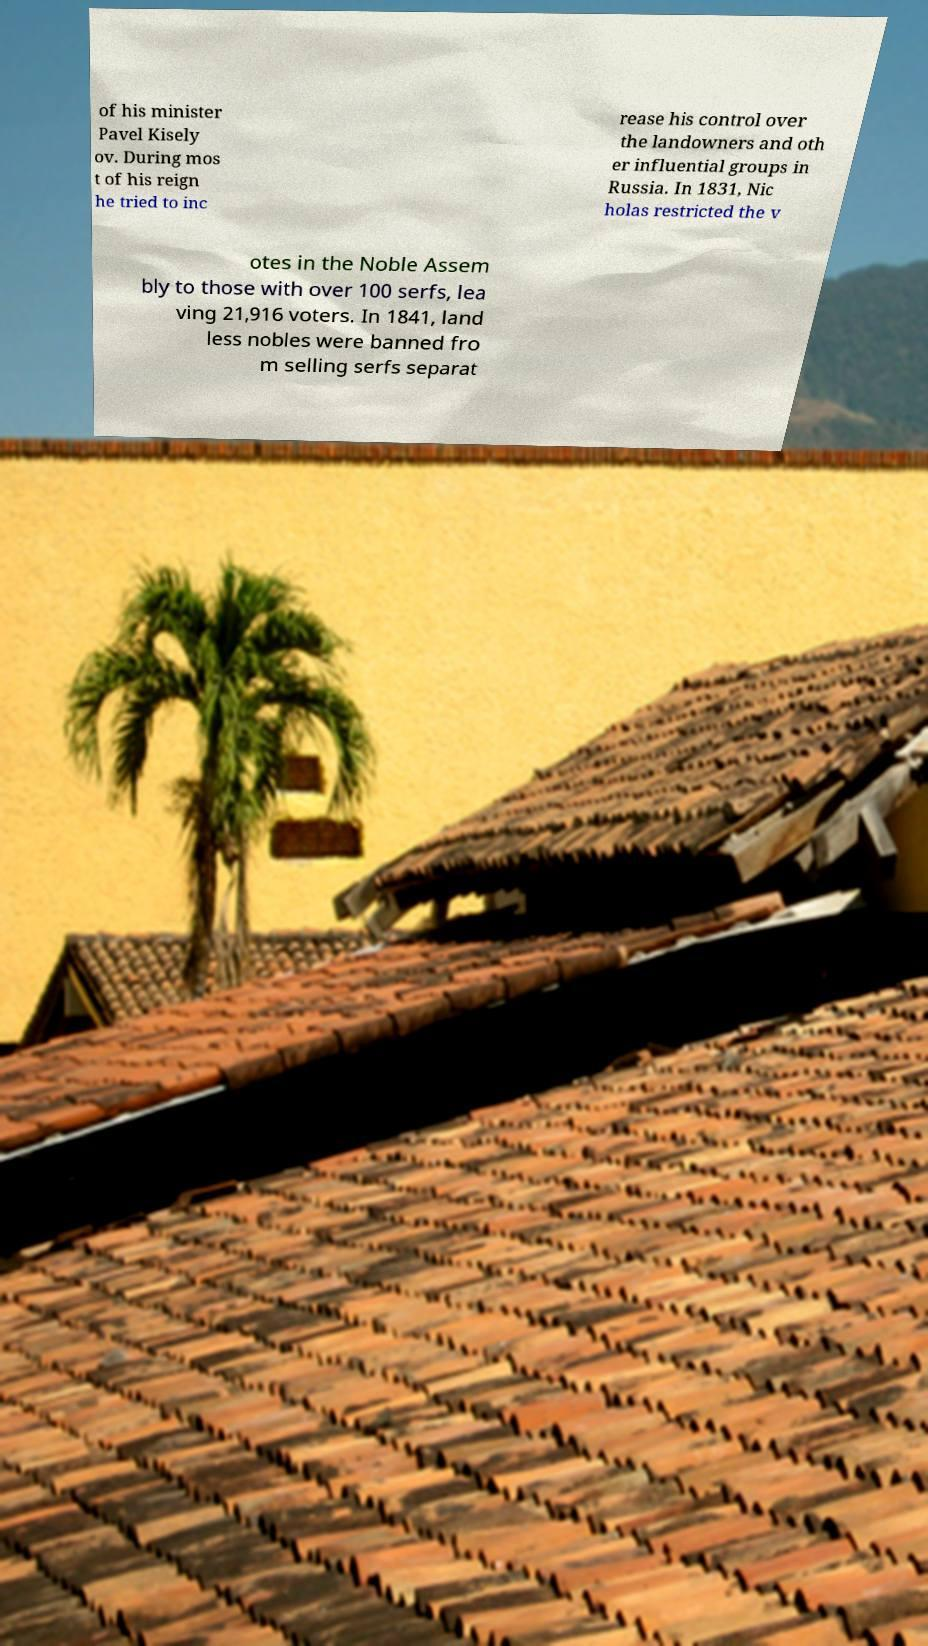There's text embedded in this image that I need extracted. Can you transcribe it verbatim? of his minister Pavel Kisely ov. During mos t of his reign he tried to inc rease his control over the landowners and oth er influential groups in Russia. In 1831, Nic holas restricted the v otes in the Noble Assem bly to those with over 100 serfs, lea ving 21,916 voters. In 1841, land less nobles were banned fro m selling serfs separat 